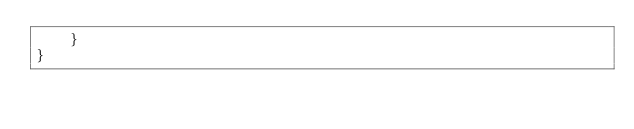Convert code to text. <code><loc_0><loc_0><loc_500><loc_500><_PHP_>    }
}
</code> 